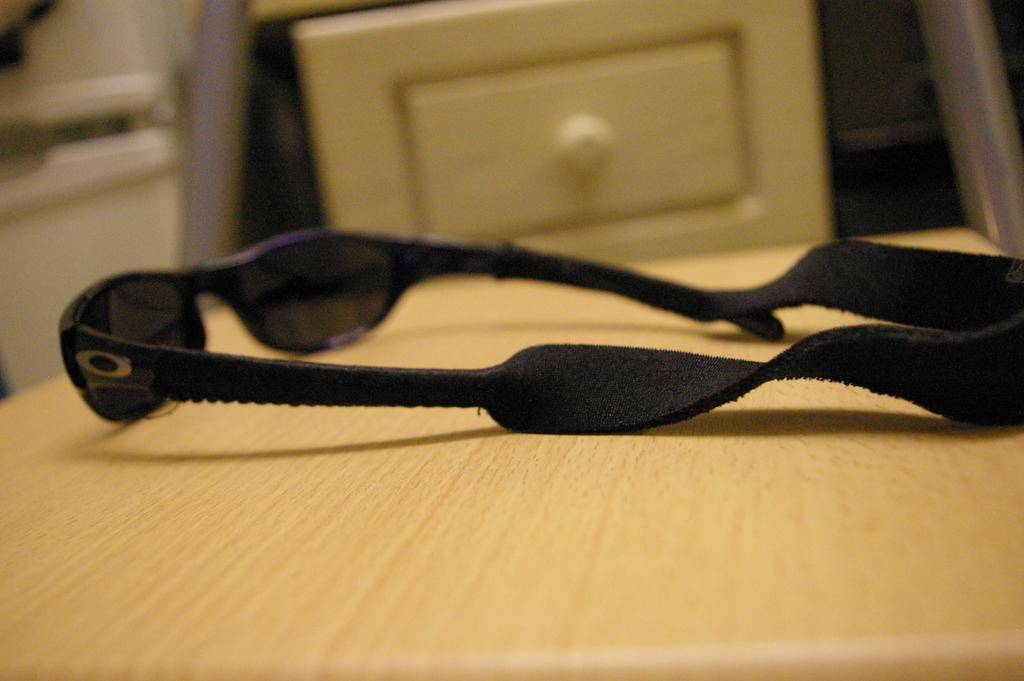What type of eyewear is on the table in the image? There are black goggles on the table. What can be seen in the background of the image? There is a drawer visible in the background. What appliance is near the wall in the image? There is a washing machine near the wall in the image. What type of metal is used to make the coal in the image? There is no coal present in the image, and therefore no metal can be associated with it. Is there an umbrella visible in the image? No, there is no umbrella present in the image. 